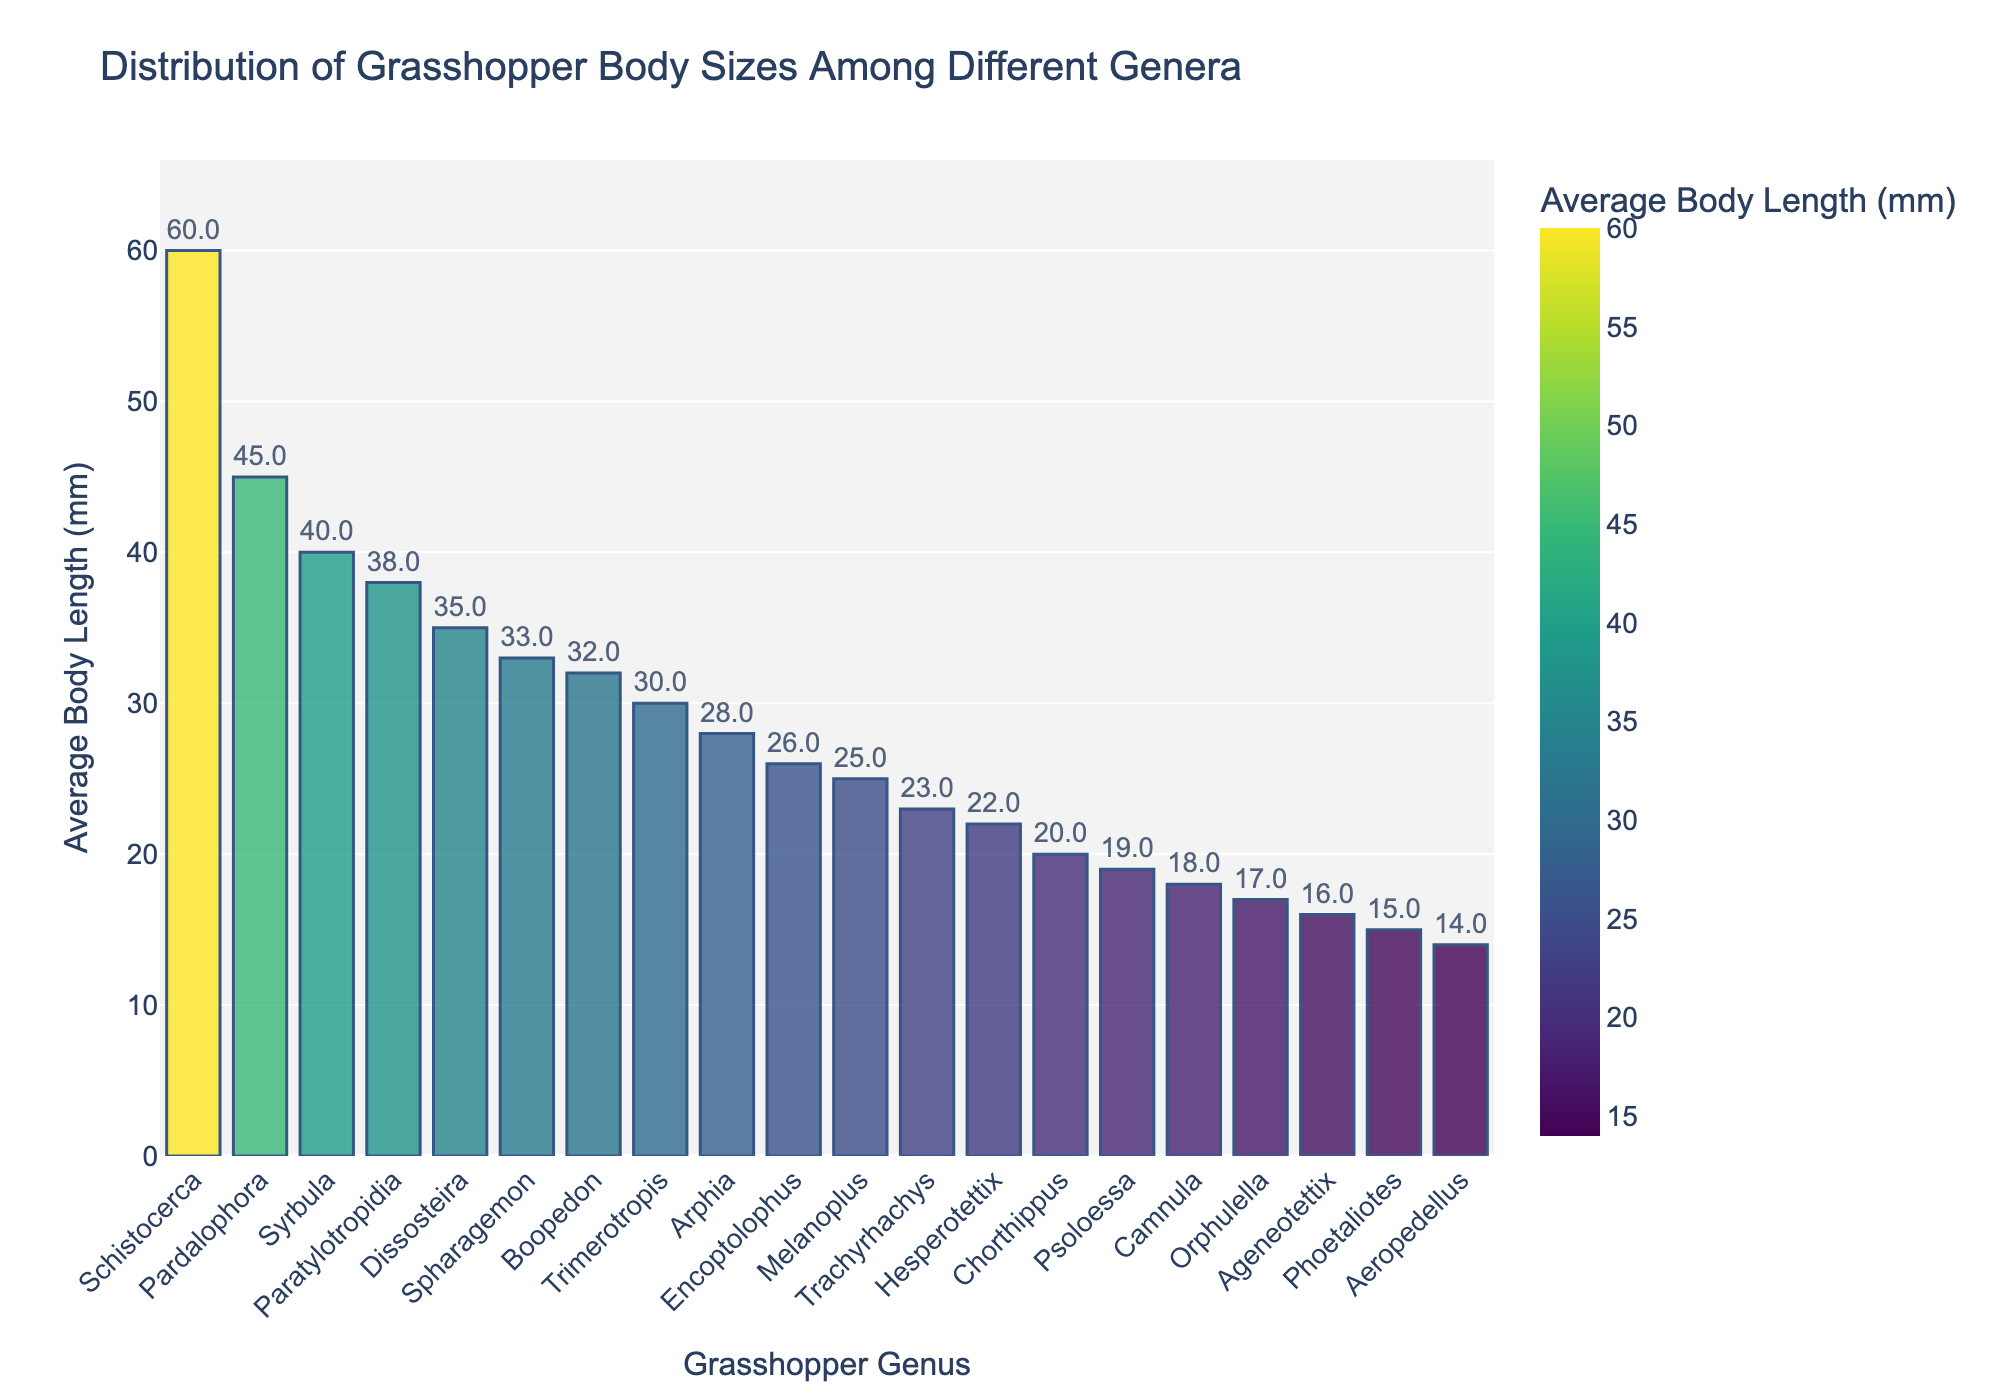Which genus has the largest average body length? Identify the tallest bar on the chart and match it with the genus label.
Answer: Schistocerca Which genus has the smallest average body length? Identify the shortest bar on the chart and match it with the genus label.
Answer: Aeropedellus What is the difference in average body length between Schistocerca and Phoetaliotes? Find the heights of the bars for Schistocerca and Phoetaliotes, then subtract the value of Phoetaliotes from Schistocerca (60 mm - 15 mm).
Answer: 45 mm Which genera have an average body length greater than 30 mm? Identify all bars exceeding the 30 mm mark and list their genus names.
Answer: Schistocerca, Dissosteira, Syrbula, Boopedon, Spharagemon, Paratylotropidia, Pardalophora What is the average body length across all genera shown? Sum the average body lengths of all genera and divide by the number of genera. ((25+60+18+35+30+28+20+40+32+22+15+17+33+38+14+45+26+23+19+16)/20 = 29.7 mm)
Answer: 29.7 mm Which genus has a body length closest to the overall average body length? Compare the overall average with each genus's body length and find the one with the smallest difference from 29.7 mm.
Answer: Encoptolophus Which genera have a body length within 5 mm of Pardalophora? Identify genera with average body lengths in the range of 40 to 50 mm, since Pardalophora is 45 mm.
Answer: Syrbula, Paratylotropidia What is the median average body length of the genera? Arrange the body lengths in ascending order and find the middle value. The sorted values are [14, 15, 16, 17, 18, 19, 20, 22, 23, 25, 26, 28, 30, 32, 33, 35, 38, 40, 45, 60]. The median is the average of 26 and 28.
Answer: 27 mm 